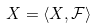<formula> <loc_0><loc_0><loc_500><loc_500>X = \langle X , { \mathcal { F } } \rangle</formula> 